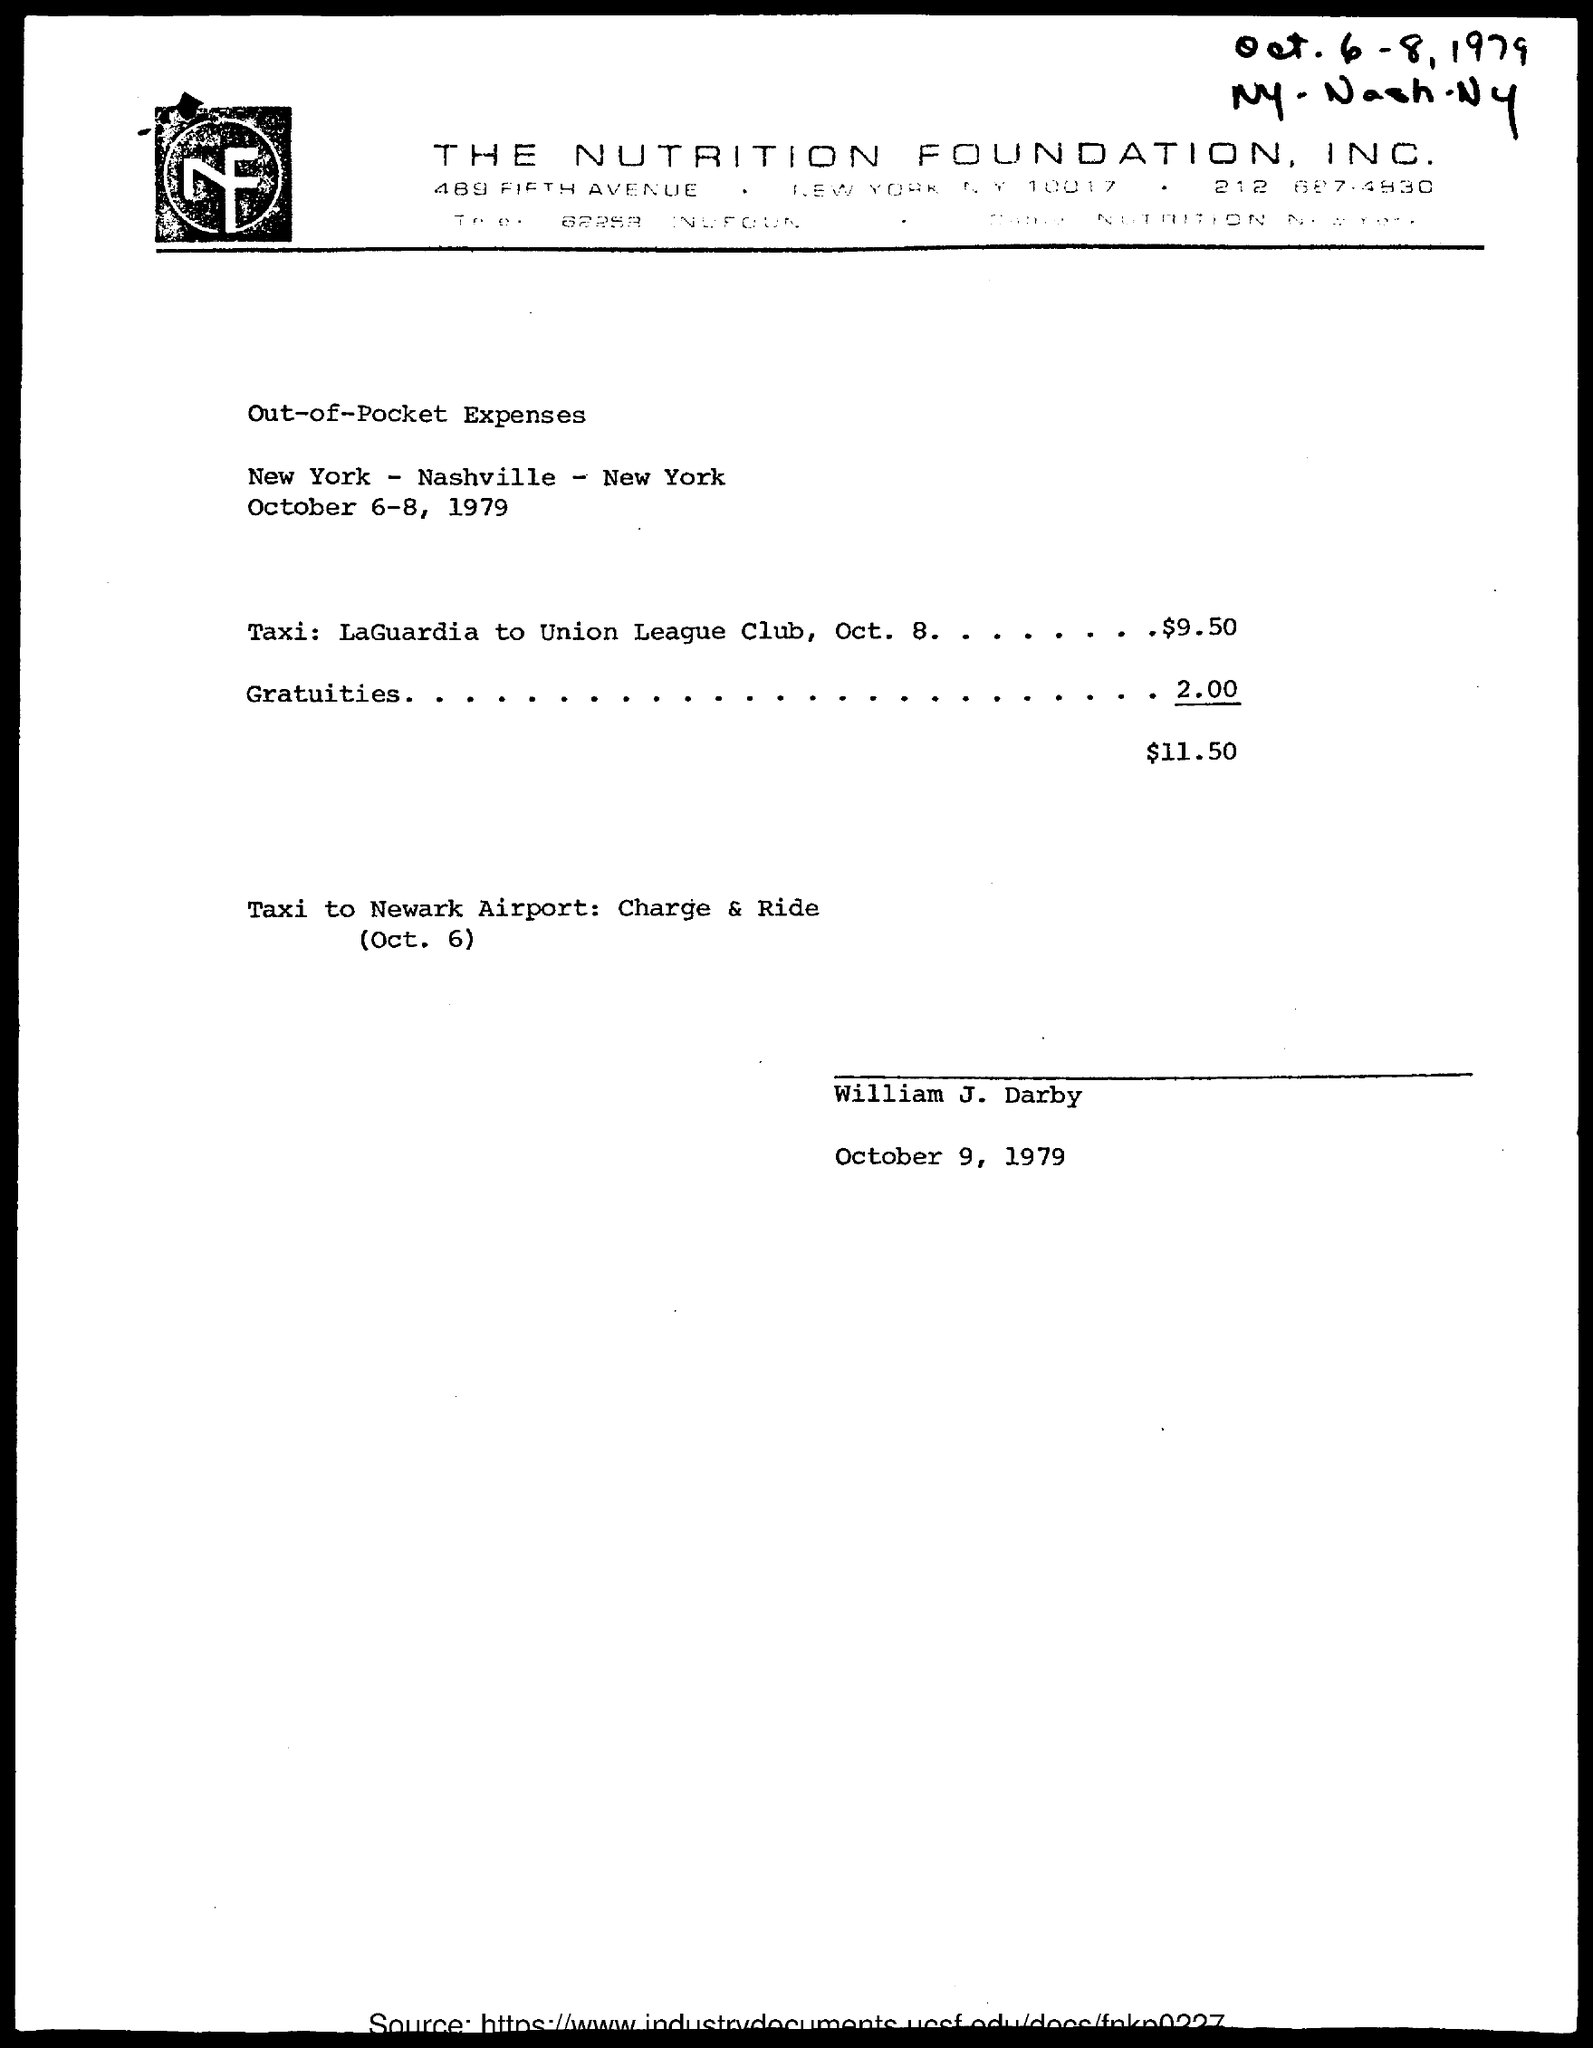What is the Title of the document?
Your answer should be compact. Out-of-Pocket Expenses. What is the date on the document?
Make the answer very short. October 6-8, 1979. What is the amount for Taxi: LaGuardia to Union League Club, Oct. 8?
Provide a succinct answer. $9.50. What is the amount for Gratuities?
Your response must be concise. 2.00. 